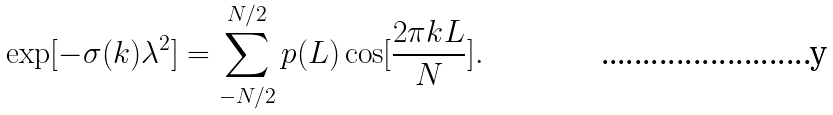<formula> <loc_0><loc_0><loc_500><loc_500>\exp [ - \sigma ( k ) \lambda ^ { 2 } ] = \sum _ { - N / 2 } ^ { N / 2 } p ( L ) \cos [ \frac { 2 \pi k L } { N } ] .</formula> 